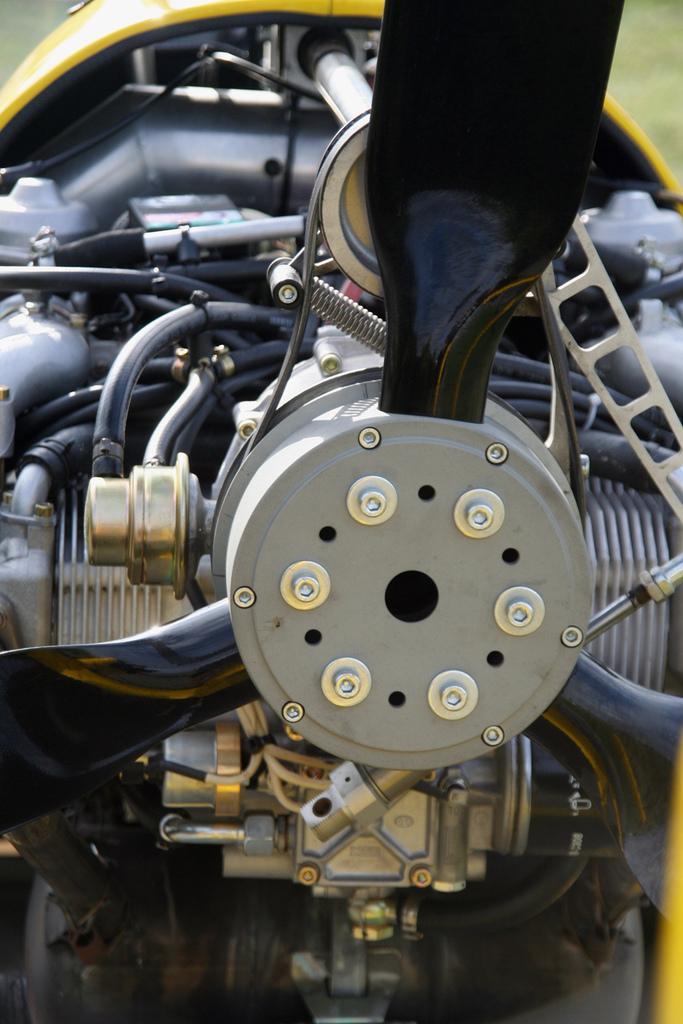In one or two sentences, can you explain what this image depicts? In the picture I can see the engine parts of a vehicle. 